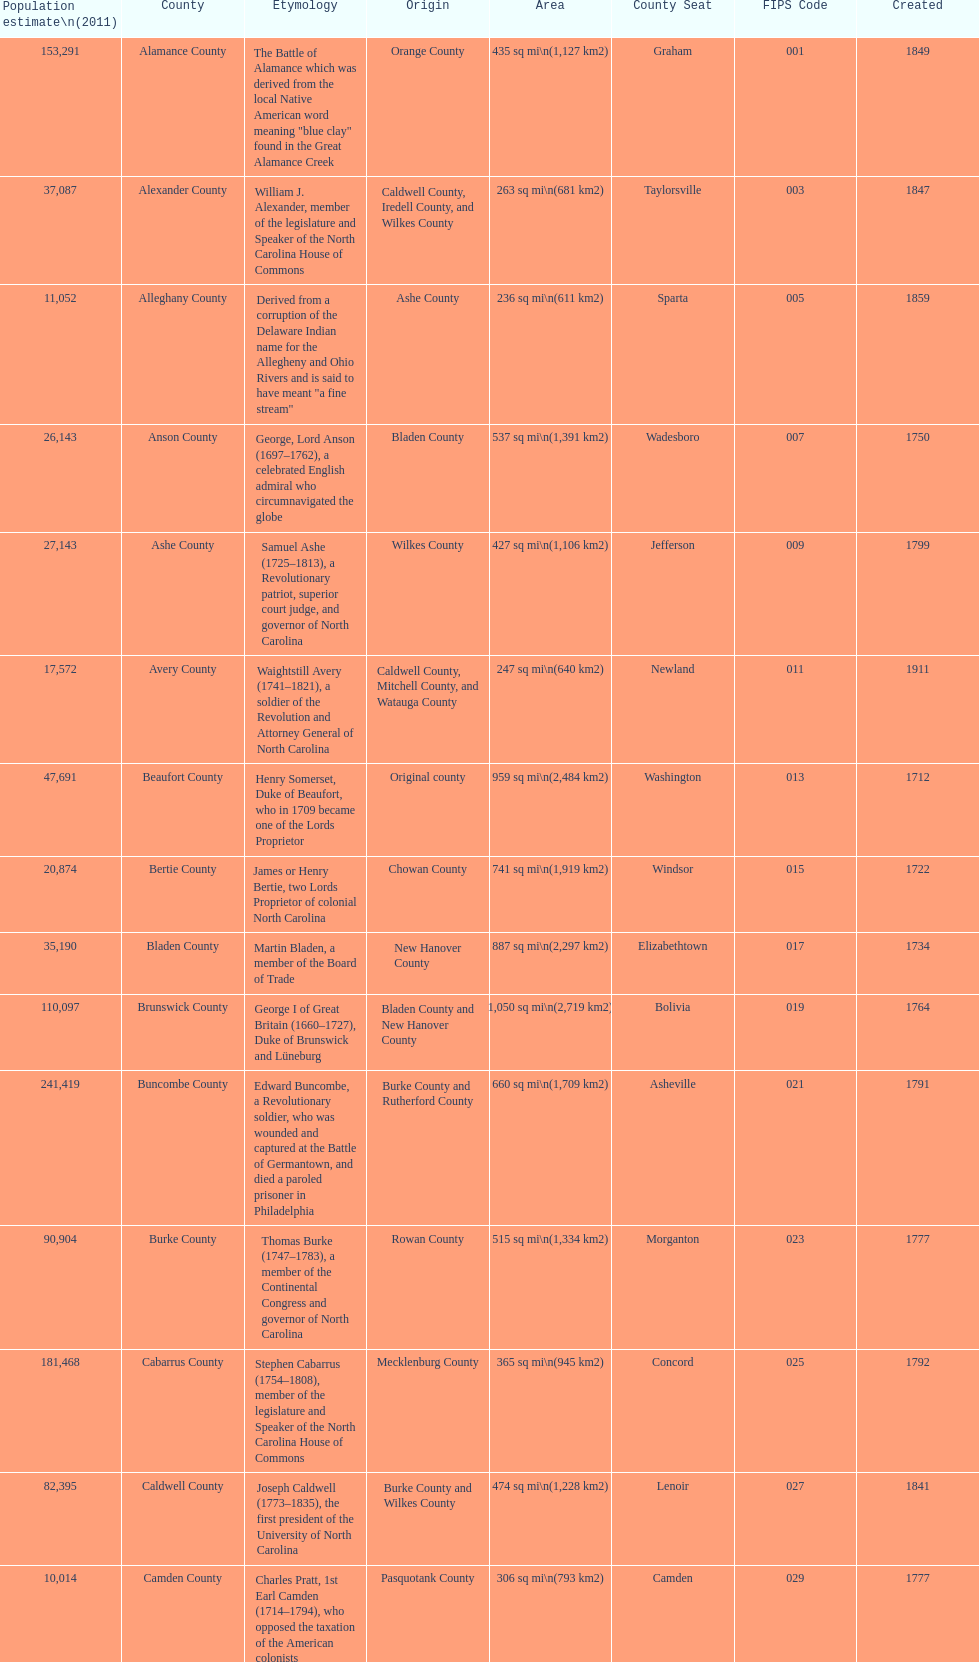Which county has a higher population, alamance or alexander? Alamance County. 